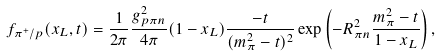<formula> <loc_0><loc_0><loc_500><loc_500>f _ { \pi ^ { + } / p } ( x _ { L } , t ) = \frac { 1 } { 2 \pi } \frac { g ^ { 2 } _ { p \pi n } } { 4 \pi } ( 1 - x _ { L } ) \frac { - t } { ( m _ { \pi } ^ { 2 } - t ) ^ { 2 } } \exp \left ( - R ^ { 2 } _ { \pi n } \frac { m ^ { 2 } _ { \pi } - t } { 1 - x _ { L } } \right ) ,</formula> 